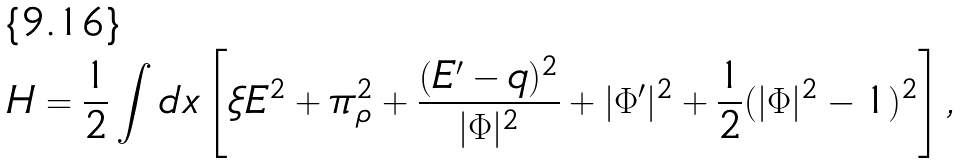Convert formula to latex. <formula><loc_0><loc_0><loc_500><loc_500>H = { \frac { 1 } { 2 } } \int d x \left [ \xi E ^ { 2 } + \pi _ { \rho } ^ { 2 } + { \frac { ( E ^ { \prime } - q ) ^ { 2 } } { | \Phi | ^ { 2 } } } + | \Phi ^ { \prime } | ^ { 2 } + { \frac { 1 } { 2 } } ( | \Phi | ^ { 2 } - 1 ) ^ { 2 } \right ] ,</formula> 